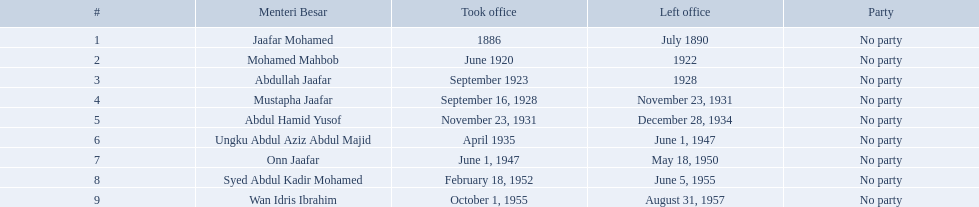Who were the menteri besar of johor? Jaafar Mohamed, Mohamed Mahbob, Abdullah Jaafar, Mustapha Jaafar, Abdul Hamid Yusof, Ungku Abdul Aziz Abdul Majid, Onn Jaafar, Syed Abdul Kadir Mohamed, Wan Idris Ibrahim. Who served the longest? Ungku Abdul Aziz Abdul Majid. Who are all the chief ministers? Jaafar Mohamed, Mohamed Mahbob, Abdullah Jaafar, Mustapha Jaafar, Abdul Hamid Yusof, Ungku Abdul Aziz Abdul Majid, Onn Jaafar, Syed Abdul Kadir Mohamed, Wan Idris Ibrahim. When did each assume office? 1886, June 1920, September 1923, September 16, 1928, November 23, 1931, April 1935, June 1, 1947, February 18, 1952, October 1, 1955. When did they depart? July 1890, 1922, 1928, November 23, 1931, December 28, 1934, June 1, 1947, May 18, 1950, June 5, 1955, August 31, 1957. And which one had the longest tenure? Ungku Abdul Aziz Abdul Majid. Who occupied the post of menteri besar in johor? Jaafar Mohamed, Mohamed Mahbob, Abdullah Jaafar, Mustapha Jaafar, Abdul Hamid Yusof, Ungku Abdul Aziz Abdul Majid, Onn Jaafar, Syed Abdul Kadir Mohamed, Wan Idris Ibrahim. Who served for the longest period? Ungku Abdul Aziz Abdul Majid. Who held the menteri besar role in johor? Jaafar Mohamed, Mohamed Mahbob, Abdullah Jaafar, Mustapha Jaafar, Abdul Hamid Yusof, Ungku Abdul Aziz Abdul Majid, Onn Jaafar, Syed Abdul Kadir Mohamed, Wan Idris Ibrahim. Who had the lengthiest tenure? Ungku Abdul Aziz Abdul Majid. When was jaafar mohamed's office commencement? 1886. When did mohamed mahbob start his term? June 1920. Who had an office period of up to 4 years? Mohamed Mahbob. When did jaafar mohamed enter office? 1886. When was the start of mohamed mahbob's term? June 1920. Who served in office for not more than 4 years? Mohamed Mahbob. 